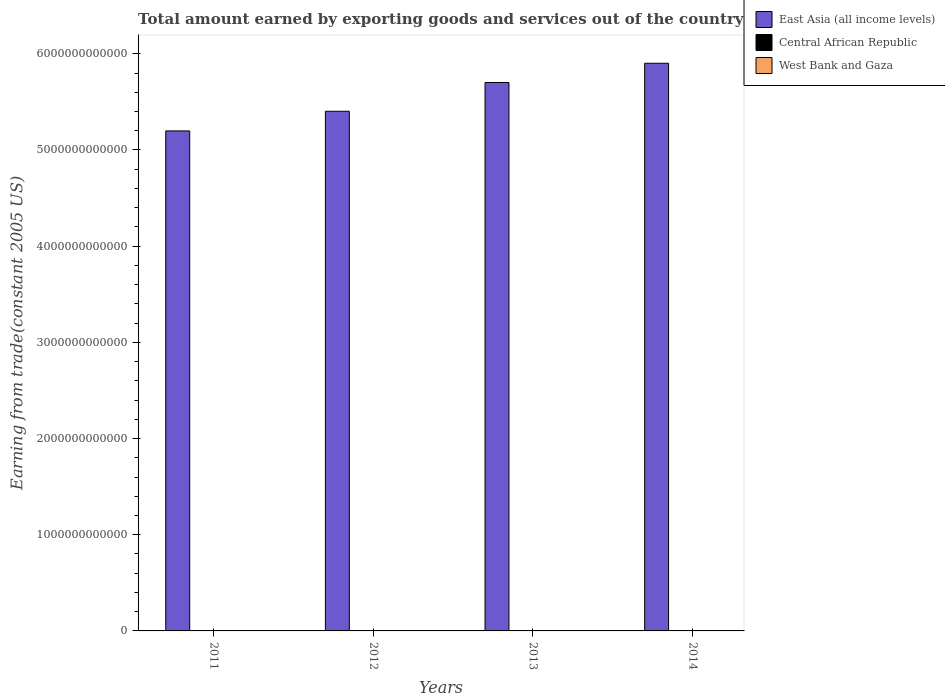How many different coloured bars are there?
Your answer should be compact. 3. How many groups of bars are there?
Your answer should be compact. 4. Are the number of bars per tick equal to the number of legend labels?
Your response must be concise. Yes. Are the number of bars on each tick of the X-axis equal?
Offer a terse response. Yes. What is the total amount earned by exporting goods and services in East Asia (all income levels) in 2011?
Provide a short and direct response. 5.20e+12. Across all years, what is the maximum total amount earned by exporting goods and services in Central African Republic?
Offer a very short reply. 1.85e+08. Across all years, what is the minimum total amount earned by exporting goods and services in East Asia (all income levels)?
Keep it short and to the point. 5.20e+12. In which year was the total amount earned by exporting goods and services in East Asia (all income levels) maximum?
Ensure brevity in your answer.  2014. What is the total total amount earned by exporting goods and services in West Bank and Gaza in the graph?
Make the answer very short. 4.52e+09. What is the difference between the total amount earned by exporting goods and services in Central African Republic in 2013 and that in 2014?
Offer a terse response. 1.92e+07. What is the difference between the total amount earned by exporting goods and services in West Bank and Gaza in 2012 and the total amount earned by exporting goods and services in East Asia (all income levels) in 2013?
Ensure brevity in your answer.  -5.70e+12. What is the average total amount earned by exporting goods and services in West Bank and Gaza per year?
Your answer should be very brief. 1.13e+09. In the year 2013, what is the difference between the total amount earned by exporting goods and services in East Asia (all income levels) and total amount earned by exporting goods and services in West Bank and Gaza?
Provide a short and direct response. 5.70e+12. What is the ratio of the total amount earned by exporting goods and services in East Asia (all income levels) in 2012 to that in 2014?
Ensure brevity in your answer.  0.92. Is the total amount earned by exporting goods and services in West Bank and Gaza in 2012 less than that in 2014?
Give a very brief answer. Yes. Is the difference between the total amount earned by exporting goods and services in East Asia (all income levels) in 2011 and 2012 greater than the difference between the total amount earned by exporting goods and services in West Bank and Gaza in 2011 and 2012?
Make the answer very short. No. What is the difference between the highest and the second highest total amount earned by exporting goods and services in West Bank and Gaza?
Offer a terse response. 7.79e+07. What is the difference between the highest and the lowest total amount earned by exporting goods and services in East Asia (all income levels)?
Make the answer very short. 7.03e+11. In how many years, is the total amount earned by exporting goods and services in Central African Republic greater than the average total amount earned by exporting goods and services in Central African Republic taken over all years?
Make the answer very short. 2. What does the 2nd bar from the left in 2013 represents?
Provide a short and direct response. Central African Republic. What does the 1st bar from the right in 2014 represents?
Your answer should be compact. West Bank and Gaza. Is it the case that in every year, the sum of the total amount earned by exporting goods and services in Central African Republic and total amount earned by exporting goods and services in West Bank and Gaza is greater than the total amount earned by exporting goods and services in East Asia (all income levels)?
Provide a short and direct response. No. How many bars are there?
Provide a succinct answer. 12. Are all the bars in the graph horizontal?
Offer a terse response. No. What is the difference between two consecutive major ticks on the Y-axis?
Provide a succinct answer. 1.00e+12. Are the values on the major ticks of Y-axis written in scientific E-notation?
Offer a terse response. No. Does the graph contain any zero values?
Provide a succinct answer. No. Where does the legend appear in the graph?
Make the answer very short. Top right. How many legend labels are there?
Give a very brief answer. 3. How are the legend labels stacked?
Your answer should be very brief. Vertical. What is the title of the graph?
Offer a very short reply. Total amount earned by exporting goods and services out of the country. What is the label or title of the X-axis?
Your answer should be very brief. Years. What is the label or title of the Y-axis?
Offer a terse response. Earning from trade(constant 2005 US). What is the Earning from trade(constant 2005 US) in East Asia (all income levels) in 2011?
Ensure brevity in your answer.  5.20e+12. What is the Earning from trade(constant 2005 US) of Central African Republic in 2011?
Offer a very short reply. 1.73e+08. What is the Earning from trade(constant 2005 US) in West Bank and Gaza in 2011?
Provide a short and direct response. 1.06e+09. What is the Earning from trade(constant 2005 US) of East Asia (all income levels) in 2012?
Your response must be concise. 5.40e+12. What is the Earning from trade(constant 2005 US) of Central African Republic in 2012?
Your response must be concise. 1.85e+08. What is the Earning from trade(constant 2005 US) in West Bank and Gaza in 2012?
Provide a short and direct response. 1.14e+09. What is the Earning from trade(constant 2005 US) of East Asia (all income levels) in 2013?
Keep it short and to the point. 5.70e+12. What is the Earning from trade(constant 2005 US) of Central African Republic in 2013?
Your response must be concise. 1.32e+08. What is the Earning from trade(constant 2005 US) in West Bank and Gaza in 2013?
Your answer should be very brief. 1.10e+09. What is the Earning from trade(constant 2005 US) of East Asia (all income levels) in 2014?
Offer a very short reply. 5.90e+12. What is the Earning from trade(constant 2005 US) in Central African Republic in 2014?
Your response must be concise. 1.12e+08. What is the Earning from trade(constant 2005 US) of West Bank and Gaza in 2014?
Provide a succinct answer. 1.21e+09. Across all years, what is the maximum Earning from trade(constant 2005 US) in East Asia (all income levels)?
Provide a succinct answer. 5.90e+12. Across all years, what is the maximum Earning from trade(constant 2005 US) of Central African Republic?
Offer a very short reply. 1.85e+08. Across all years, what is the maximum Earning from trade(constant 2005 US) in West Bank and Gaza?
Your response must be concise. 1.21e+09. Across all years, what is the minimum Earning from trade(constant 2005 US) of East Asia (all income levels)?
Provide a succinct answer. 5.20e+12. Across all years, what is the minimum Earning from trade(constant 2005 US) in Central African Republic?
Make the answer very short. 1.12e+08. Across all years, what is the minimum Earning from trade(constant 2005 US) in West Bank and Gaza?
Provide a succinct answer. 1.06e+09. What is the total Earning from trade(constant 2005 US) of East Asia (all income levels) in the graph?
Keep it short and to the point. 2.22e+13. What is the total Earning from trade(constant 2005 US) in Central African Republic in the graph?
Make the answer very short. 6.02e+08. What is the total Earning from trade(constant 2005 US) of West Bank and Gaza in the graph?
Your answer should be compact. 4.52e+09. What is the difference between the Earning from trade(constant 2005 US) of East Asia (all income levels) in 2011 and that in 2012?
Ensure brevity in your answer.  -2.04e+11. What is the difference between the Earning from trade(constant 2005 US) of Central African Republic in 2011 and that in 2012?
Provide a short and direct response. -1.22e+07. What is the difference between the Earning from trade(constant 2005 US) of West Bank and Gaza in 2011 and that in 2012?
Keep it short and to the point. -7.32e+07. What is the difference between the Earning from trade(constant 2005 US) in East Asia (all income levels) in 2011 and that in 2013?
Your answer should be compact. -5.03e+11. What is the difference between the Earning from trade(constant 2005 US) in Central African Republic in 2011 and that in 2013?
Your answer should be compact. 4.12e+07. What is the difference between the Earning from trade(constant 2005 US) in West Bank and Gaza in 2011 and that in 2013?
Provide a succinct answer. -3.79e+07. What is the difference between the Earning from trade(constant 2005 US) of East Asia (all income levels) in 2011 and that in 2014?
Provide a short and direct response. -7.03e+11. What is the difference between the Earning from trade(constant 2005 US) of Central African Republic in 2011 and that in 2014?
Your answer should be very brief. 6.04e+07. What is the difference between the Earning from trade(constant 2005 US) in West Bank and Gaza in 2011 and that in 2014?
Offer a terse response. -1.51e+08. What is the difference between the Earning from trade(constant 2005 US) in East Asia (all income levels) in 2012 and that in 2013?
Your answer should be very brief. -2.99e+11. What is the difference between the Earning from trade(constant 2005 US) of Central African Republic in 2012 and that in 2013?
Give a very brief answer. 5.34e+07. What is the difference between the Earning from trade(constant 2005 US) of West Bank and Gaza in 2012 and that in 2013?
Offer a very short reply. 3.53e+07. What is the difference between the Earning from trade(constant 2005 US) of East Asia (all income levels) in 2012 and that in 2014?
Provide a short and direct response. -4.99e+11. What is the difference between the Earning from trade(constant 2005 US) of Central African Republic in 2012 and that in 2014?
Your answer should be very brief. 7.26e+07. What is the difference between the Earning from trade(constant 2005 US) of West Bank and Gaza in 2012 and that in 2014?
Make the answer very short. -7.79e+07. What is the difference between the Earning from trade(constant 2005 US) in East Asia (all income levels) in 2013 and that in 2014?
Make the answer very short. -2.00e+11. What is the difference between the Earning from trade(constant 2005 US) of Central African Republic in 2013 and that in 2014?
Keep it short and to the point. 1.92e+07. What is the difference between the Earning from trade(constant 2005 US) in West Bank and Gaza in 2013 and that in 2014?
Offer a terse response. -1.13e+08. What is the difference between the Earning from trade(constant 2005 US) in East Asia (all income levels) in 2011 and the Earning from trade(constant 2005 US) in Central African Republic in 2012?
Ensure brevity in your answer.  5.20e+12. What is the difference between the Earning from trade(constant 2005 US) in East Asia (all income levels) in 2011 and the Earning from trade(constant 2005 US) in West Bank and Gaza in 2012?
Offer a terse response. 5.20e+12. What is the difference between the Earning from trade(constant 2005 US) in Central African Republic in 2011 and the Earning from trade(constant 2005 US) in West Bank and Gaza in 2012?
Provide a succinct answer. -9.64e+08. What is the difference between the Earning from trade(constant 2005 US) of East Asia (all income levels) in 2011 and the Earning from trade(constant 2005 US) of Central African Republic in 2013?
Your answer should be very brief. 5.20e+12. What is the difference between the Earning from trade(constant 2005 US) in East Asia (all income levels) in 2011 and the Earning from trade(constant 2005 US) in West Bank and Gaza in 2013?
Your answer should be very brief. 5.20e+12. What is the difference between the Earning from trade(constant 2005 US) of Central African Republic in 2011 and the Earning from trade(constant 2005 US) of West Bank and Gaza in 2013?
Offer a very short reply. -9.29e+08. What is the difference between the Earning from trade(constant 2005 US) of East Asia (all income levels) in 2011 and the Earning from trade(constant 2005 US) of Central African Republic in 2014?
Offer a terse response. 5.20e+12. What is the difference between the Earning from trade(constant 2005 US) of East Asia (all income levels) in 2011 and the Earning from trade(constant 2005 US) of West Bank and Gaza in 2014?
Make the answer very short. 5.20e+12. What is the difference between the Earning from trade(constant 2005 US) in Central African Republic in 2011 and the Earning from trade(constant 2005 US) in West Bank and Gaza in 2014?
Keep it short and to the point. -1.04e+09. What is the difference between the Earning from trade(constant 2005 US) of East Asia (all income levels) in 2012 and the Earning from trade(constant 2005 US) of Central African Republic in 2013?
Your answer should be compact. 5.40e+12. What is the difference between the Earning from trade(constant 2005 US) in East Asia (all income levels) in 2012 and the Earning from trade(constant 2005 US) in West Bank and Gaza in 2013?
Your answer should be compact. 5.40e+12. What is the difference between the Earning from trade(constant 2005 US) of Central African Republic in 2012 and the Earning from trade(constant 2005 US) of West Bank and Gaza in 2013?
Ensure brevity in your answer.  -9.16e+08. What is the difference between the Earning from trade(constant 2005 US) in East Asia (all income levels) in 2012 and the Earning from trade(constant 2005 US) in Central African Republic in 2014?
Your answer should be very brief. 5.40e+12. What is the difference between the Earning from trade(constant 2005 US) in East Asia (all income levels) in 2012 and the Earning from trade(constant 2005 US) in West Bank and Gaza in 2014?
Keep it short and to the point. 5.40e+12. What is the difference between the Earning from trade(constant 2005 US) of Central African Republic in 2012 and the Earning from trade(constant 2005 US) of West Bank and Gaza in 2014?
Offer a very short reply. -1.03e+09. What is the difference between the Earning from trade(constant 2005 US) in East Asia (all income levels) in 2013 and the Earning from trade(constant 2005 US) in Central African Republic in 2014?
Your answer should be very brief. 5.70e+12. What is the difference between the Earning from trade(constant 2005 US) of East Asia (all income levels) in 2013 and the Earning from trade(constant 2005 US) of West Bank and Gaza in 2014?
Your answer should be compact. 5.70e+12. What is the difference between the Earning from trade(constant 2005 US) in Central African Republic in 2013 and the Earning from trade(constant 2005 US) in West Bank and Gaza in 2014?
Keep it short and to the point. -1.08e+09. What is the average Earning from trade(constant 2005 US) of East Asia (all income levels) per year?
Provide a short and direct response. 5.55e+12. What is the average Earning from trade(constant 2005 US) in Central African Republic per year?
Ensure brevity in your answer.  1.50e+08. What is the average Earning from trade(constant 2005 US) in West Bank and Gaza per year?
Your answer should be very brief. 1.13e+09. In the year 2011, what is the difference between the Earning from trade(constant 2005 US) in East Asia (all income levels) and Earning from trade(constant 2005 US) in Central African Republic?
Offer a very short reply. 5.20e+12. In the year 2011, what is the difference between the Earning from trade(constant 2005 US) of East Asia (all income levels) and Earning from trade(constant 2005 US) of West Bank and Gaza?
Provide a succinct answer. 5.20e+12. In the year 2011, what is the difference between the Earning from trade(constant 2005 US) in Central African Republic and Earning from trade(constant 2005 US) in West Bank and Gaza?
Provide a short and direct response. -8.91e+08. In the year 2012, what is the difference between the Earning from trade(constant 2005 US) of East Asia (all income levels) and Earning from trade(constant 2005 US) of Central African Republic?
Offer a terse response. 5.40e+12. In the year 2012, what is the difference between the Earning from trade(constant 2005 US) of East Asia (all income levels) and Earning from trade(constant 2005 US) of West Bank and Gaza?
Give a very brief answer. 5.40e+12. In the year 2012, what is the difference between the Earning from trade(constant 2005 US) of Central African Republic and Earning from trade(constant 2005 US) of West Bank and Gaza?
Provide a succinct answer. -9.52e+08. In the year 2013, what is the difference between the Earning from trade(constant 2005 US) in East Asia (all income levels) and Earning from trade(constant 2005 US) in Central African Republic?
Keep it short and to the point. 5.70e+12. In the year 2013, what is the difference between the Earning from trade(constant 2005 US) in East Asia (all income levels) and Earning from trade(constant 2005 US) in West Bank and Gaza?
Keep it short and to the point. 5.70e+12. In the year 2013, what is the difference between the Earning from trade(constant 2005 US) in Central African Republic and Earning from trade(constant 2005 US) in West Bank and Gaza?
Your answer should be compact. -9.70e+08. In the year 2014, what is the difference between the Earning from trade(constant 2005 US) of East Asia (all income levels) and Earning from trade(constant 2005 US) of Central African Republic?
Provide a short and direct response. 5.90e+12. In the year 2014, what is the difference between the Earning from trade(constant 2005 US) in East Asia (all income levels) and Earning from trade(constant 2005 US) in West Bank and Gaza?
Give a very brief answer. 5.90e+12. In the year 2014, what is the difference between the Earning from trade(constant 2005 US) in Central African Republic and Earning from trade(constant 2005 US) in West Bank and Gaza?
Your answer should be very brief. -1.10e+09. What is the ratio of the Earning from trade(constant 2005 US) in East Asia (all income levels) in 2011 to that in 2012?
Make the answer very short. 0.96. What is the ratio of the Earning from trade(constant 2005 US) of Central African Republic in 2011 to that in 2012?
Offer a very short reply. 0.93. What is the ratio of the Earning from trade(constant 2005 US) of West Bank and Gaza in 2011 to that in 2012?
Make the answer very short. 0.94. What is the ratio of the Earning from trade(constant 2005 US) of East Asia (all income levels) in 2011 to that in 2013?
Offer a terse response. 0.91. What is the ratio of the Earning from trade(constant 2005 US) in Central African Republic in 2011 to that in 2013?
Offer a terse response. 1.31. What is the ratio of the Earning from trade(constant 2005 US) of West Bank and Gaza in 2011 to that in 2013?
Your answer should be compact. 0.97. What is the ratio of the Earning from trade(constant 2005 US) in East Asia (all income levels) in 2011 to that in 2014?
Give a very brief answer. 0.88. What is the ratio of the Earning from trade(constant 2005 US) in Central African Republic in 2011 to that in 2014?
Make the answer very short. 1.54. What is the ratio of the Earning from trade(constant 2005 US) of West Bank and Gaza in 2011 to that in 2014?
Your answer should be very brief. 0.88. What is the ratio of the Earning from trade(constant 2005 US) of East Asia (all income levels) in 2012 to that in 2013?
Give a very brief answer. 0.95. What is the ratio of the Earning from trade(constant 2005 US) of Central African Republic in 2012 to that in 2013?
Keep it short and to the point. 1.41. What is the ratio of the Earning from trade(constant 2005 US) of West Bank and Gaza in 2012 to that in 2013?
Offer a very short reply. 1.03. What is the ratio of the Earning from trade(constant 2005 US) of East Asia (all income levels) in 2012 to that in 2014?
Provide a succinct answer. 0.92. What is the ratio of the Earning from trade(constant 2005 US) of Central African Republic in 2012 to that in 2014?
Offer a very short reply. 1.65. What is the ratio of the Earning from trade(constant 2005 US) of West Bank and Gaza in 2012 to that in 2014?
Offer a terse response. 0.94. What is the ratio of the Earning from trade(constant 2005 US) of East Asia (all income levels) in 2013 to that in 2014?
Provide a short and direct response. 0.97. What is the ratio of the Earning from trade(constant 2005 US) of Central African Republic in 2013 to that in 2014?
Your answer should be very brief. 1.17. What is the ratio of the Earning from trade(constant 2005 US) in West Bank and Gaza in 2013 to that in 2014?
Ensure brevity in your answer.  0.91. What is the difference between the highest and the second highest Earning from trade(constant 2005 US) in East Asia (all income levels)?
Give a very brief answer. 2.00e+11. What is the difference between the highest and the second highest Earning from trade(constant 2005 US) of Central African Republic?
Your response must be concise. 1.22e+07. What is the difference between the highest and the second highest Earning from trade(constant 2005 US) of West Bank and Gaza?
Your response must be concise. 7.79e+07. What is the difference between the highest and the lowest Earning from trade(constant 2005 US) of East Asia (all income levels)?
Make the answer very short. 7.03e+11. What is the difference between the highest and the lowest Earning from trade(constant 2005 US) of Central African Republic?
Provide a succinct answer. 7.26e+07. What is the difference between the highest and the lowest Earning from trade(constant 2005 US) of West Bank and Gaza?
Your answer should be compact. 1.51e+08. 